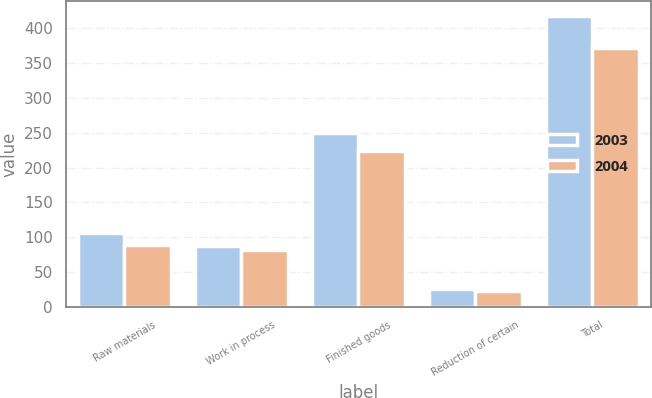Convert chart to OTSL. <chart><loc_0><loc_0><loc_500><loc_500><stacked_bar_chart><ecel><fcel>Raw materials<fcel>Work in process<fcel>Finished goods<fcel>Reduction of certain<fcel>Total<nl><fcel>2003<fcel>106.1<fcel>87.2<fcel>249.5<fcel>24.9<fcel>417.9<nl><fcel>2004<fcel>88.1<fcel>82.1<fcel>223.6<fcel>22.6<fcel>371.2<nl></chart> 